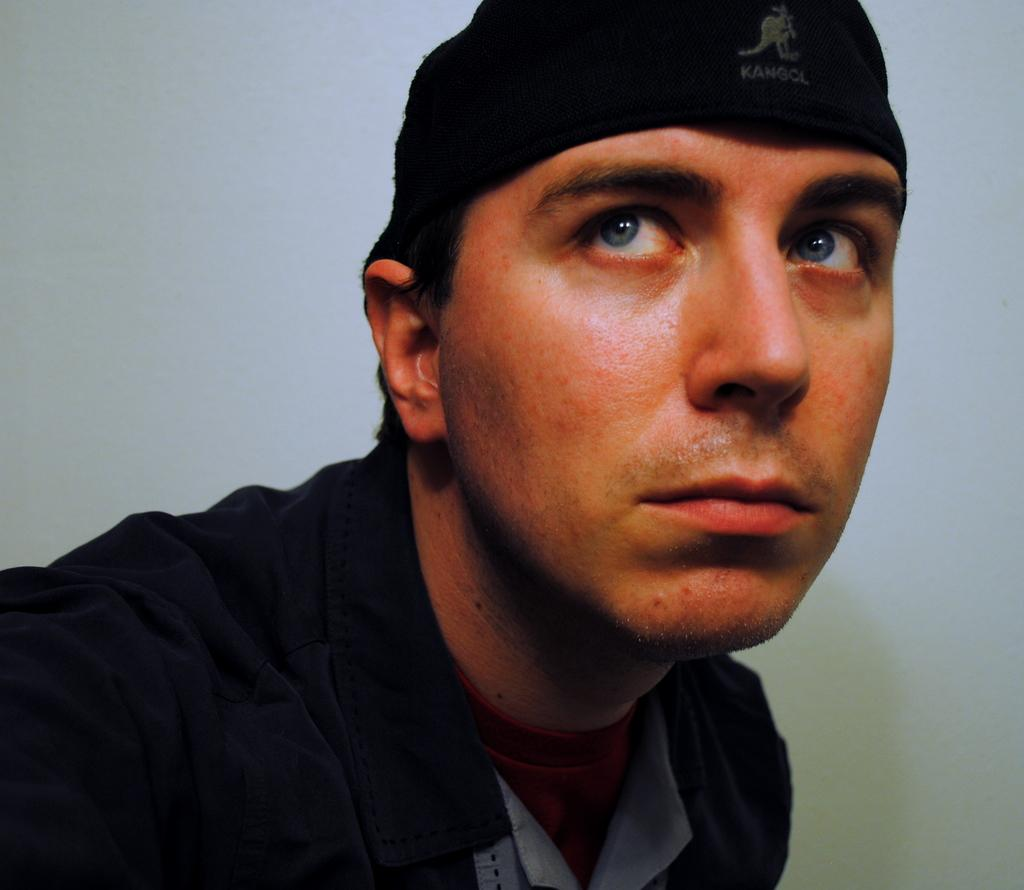Who is present in the image? There is a man in the picture. What is the man doing in the image? The man is looking outside. What color is the shirt the man is wearing? The man is wearing a black shirt. What type of headwear is the man wearing? The man is wearing a black cap. What chance does the tin have of being mentioned in the image? There is no tin present in the image, so it cannot be mentioned. 